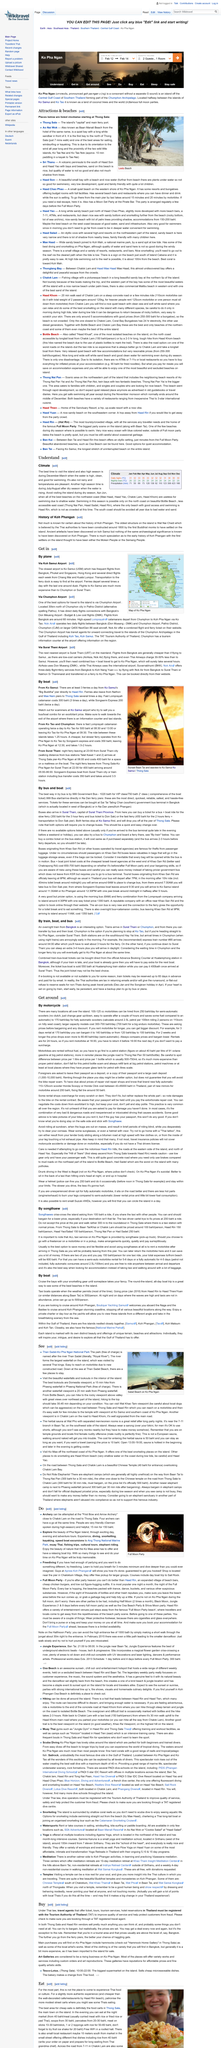Draw attention to some important aspects in this diagram. There is an average of 123 millimeters of precipitation in September. When traveling by bus, it is advisable to take the 999 Government Bus as the best option for entry. The drop off point of ferry boats is at the pier of Thong Sala, where passengers can disembark and begin their journey through the island. It is possible to view the islands from a unique perspective by embarking on a private charter or day tour on a yacht. In Ko Pha Ngan, the main purchases made by tourists would include hammocks and locally created artworks. 